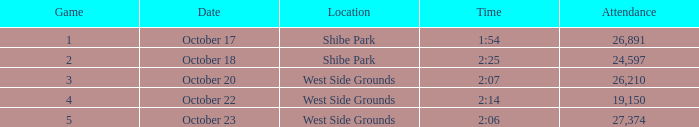Which week was the first game played that had a time of 2:06 and less than 27,374 attendees? None. 